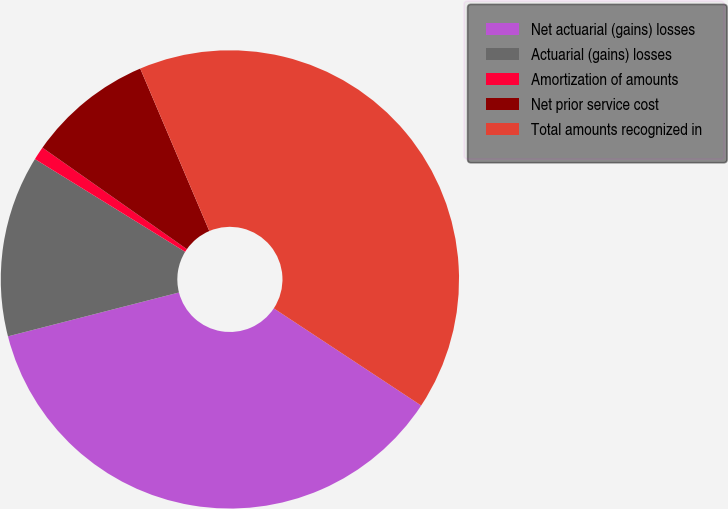Convert chart to OTSL. <chart><loc_0><loc_0><loc_500><loc_500><pie_chart><fcel>Net actuarial (gains) losses<fcel>Actuarial (gains) losses<fcel>Amortization of amounts<fcel>Net prior service cost<fcel>Total amounts recognized in<nl><fcel>36.73%<fcel>12.8%<fcel>0.95%<fcel>8.85%<fcel>40.68%<nl></chart> 